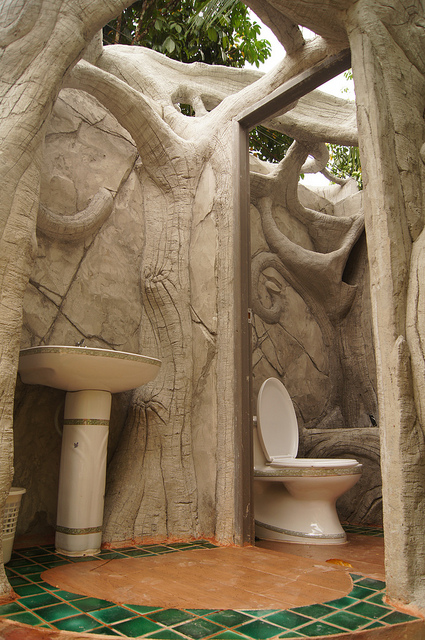<image>How large is the statue? It is unknown how large the statue is. It can be described as large or even very large. How large is the statue? I am not sure how large the statue is. But it can be seen as very large or large. 